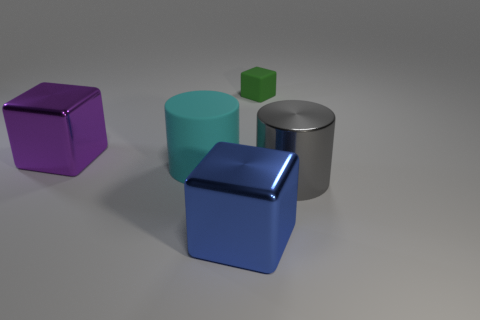Subtract 1 blocks. How many blocks are left? 2 Add 1 matte things. How many objects exist? 6 Subtract all cubes. How many objects are left? 2 Add 5 big cyan things. How many big cyan things are left? 6 Add 5 purple metal things. How many purple metal things exist? 6 Subtract 0 yellow cubes. How many objects are left? 5 Subtract all gray shiny balls. Subtract all shiny objects. How many objects are left? 2 